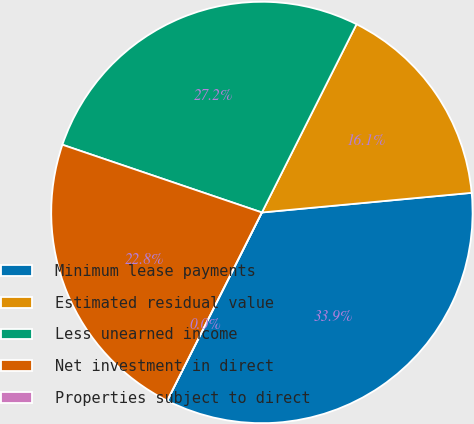Convert chart. <chart><loc_0><loc_0><loc_500><loc_500><pie_chart><fcel>Minimum lease payments<fcel>Estimated residual value<fcel>Less unearned income<fcel>Net investment in direct<fcel>Properties subject to direct<nl><fcel>33.9%<fcel>16.1%<fcel>27.2%<fcel>22.79%<fcel>0.0%<nl></chart> 